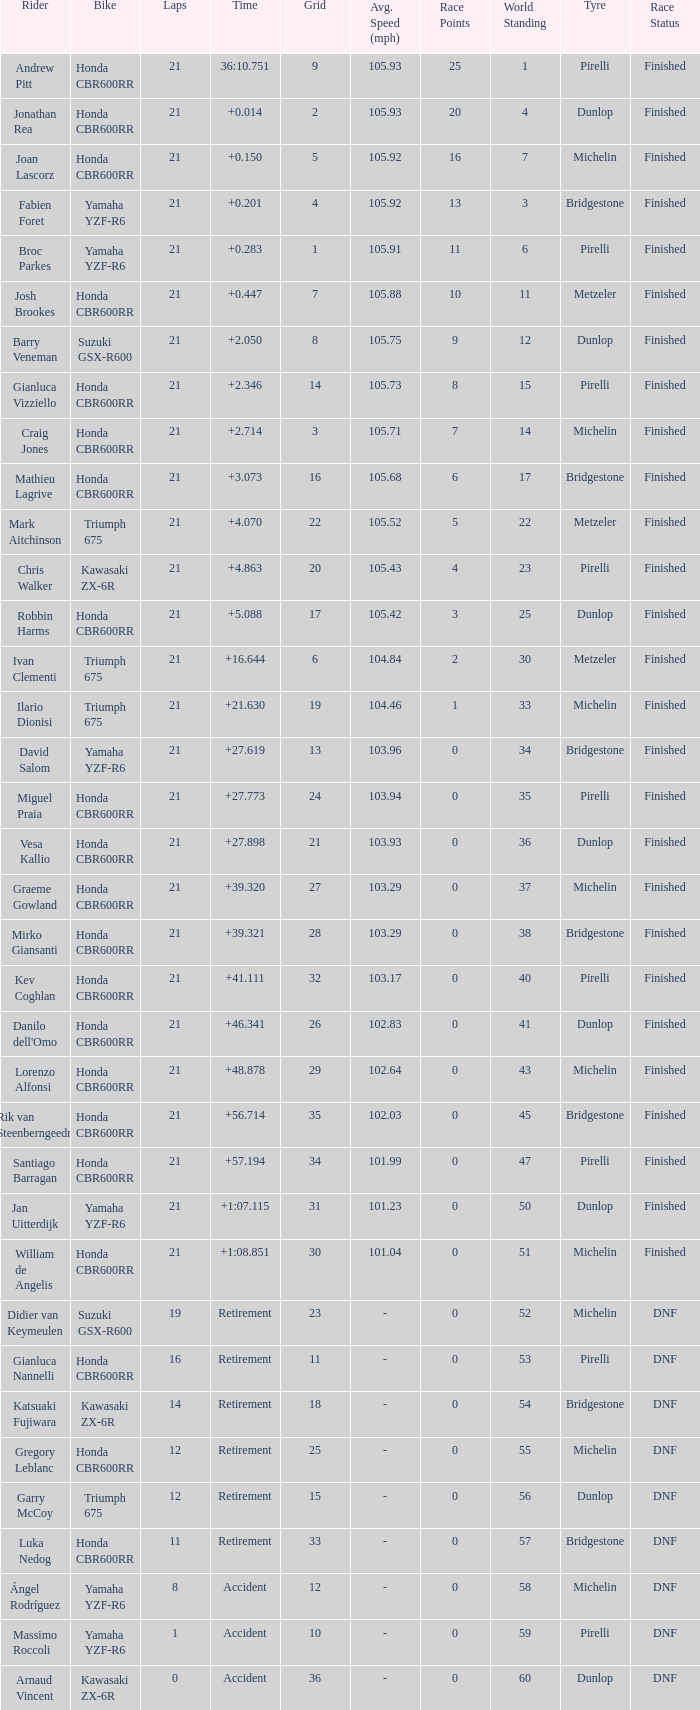What is the total of laps run by the driver with a grid under 17 and a time of +5.088? None. 